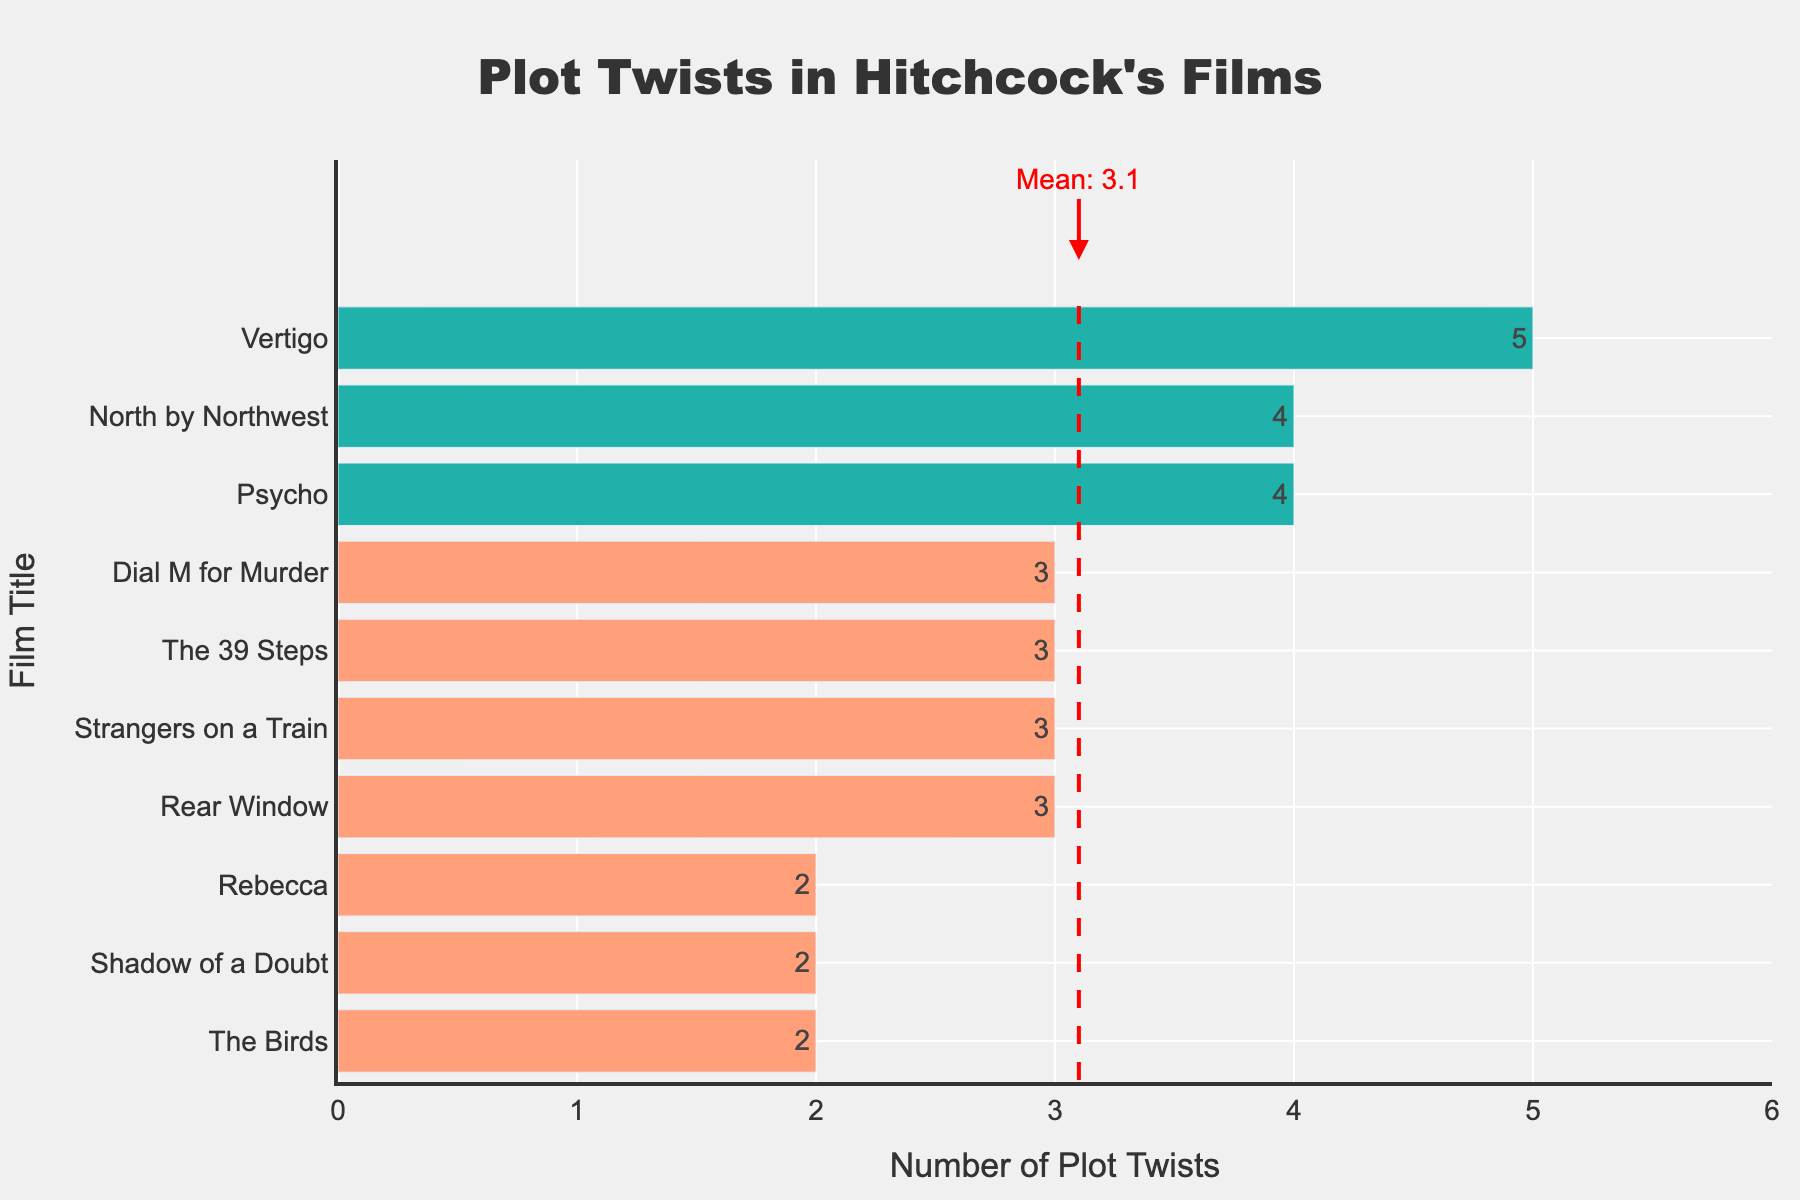What's the mean number of plot twists in the films? A vertical red dashed line is drawn at the mean number of plot twists, which is labelled. From the annotation, we see that the mean number of plot twists is 3.1.
Answer: 3.1 Which film has the highest number of plot twists, and what is the viewer satisfaction for that film? By observing the lengths of the bars, "Vertigo" stands out with the longest bar for plot twists at 5. The corresponding hover text shows a viewer satisfaction of 8.5.
Answer: Vertigo, 8.5 How many films have plot twists above the mean? The mean is 3.1, marked by the red dashed line. By counting the bars to the right of this line, we find that "Psycho", "Vertigo", and "North by Northwest" have plot twists above the mean.
Answer: 3 Which film has the lowest viewer satisfaction, and how many plot twists does it have? By examining the hover text, "The Birds" has the lowest viewer satisfaction at 7.4 and it has 2 plot twists.
Answer: The Birds, 2 Do films with fewer plot twists (below the mean) generally have lower viewer satisfaction? To answer this, compare the viewer satisfaction for films with plot twists below the mean (2, 2, 2, 3, 3, 3) with those above (4, 4, 5). The hover text shows that films with fewer plot twists don't consistently have lower viewer satisfaction (e.g., "Rebecca" with 2 plot twists has 8.3).
Answer: No What is the total number of plot twists in all the films? Summing up the plot twists for each film (4 + 3 + 5 + 4 + 2 + 3 + 2 + 3 + 2 + 3), we get 31.
Answer: 31 Which film has the same number of plot twists as the mean value? The mean value of plot twists is 3.1, but no film has exactly 3.1 plot twists.
Answer: None Among films with 3 plot twists, which one has the highest viewer satisfaction? Films with 3 plot twists are "Rear Window", "Strangers on a Train", "The 39 Steps", and "Dial M for Murder". By comparing viewer satisfaction from the hover text: "Rear Window" (8.8) has the highest.
Answer: Rear Window What is the difference in viewer satisfaction between the film with the most plot twists and the film with the least plot twists? "Vertigo" has the most plot twists (5) and a viewer satisfaction of 8.5. "The Birds", "Shadow of a Doubt", and "Rebecca" have the least plot twists (2), with viewer satisfaction scores of 7.4, 7.8, and 8.3, respectively. The largest difference is between "Vertigo" and "The Birds", i.e., 8.5 - 7.4 = 1.1.
Answer: 1.1 